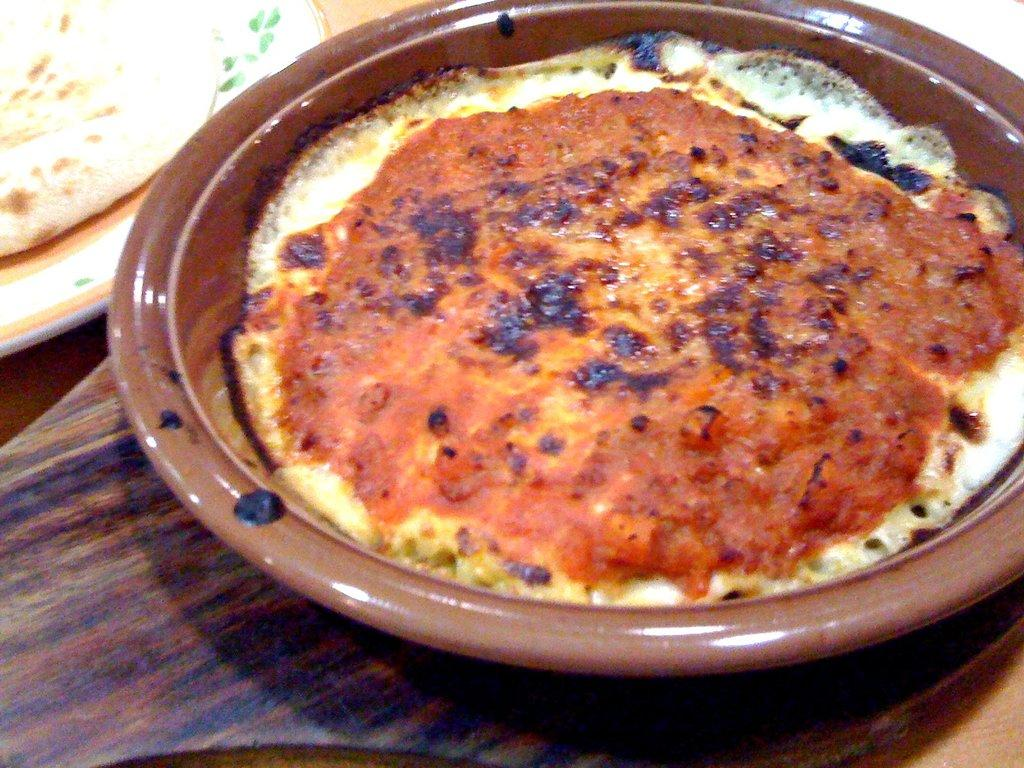What is in the bowl that is visible in the image? There are food items in a bowl in the image. What is on the plate in the image? There is an object in a plate in the image. What type of surface is visible in the image? The wooden surface is present in the image. What type of memory is stored in the object on the plate? There is no indication in the image that the object on the plate is related to memory storage. 